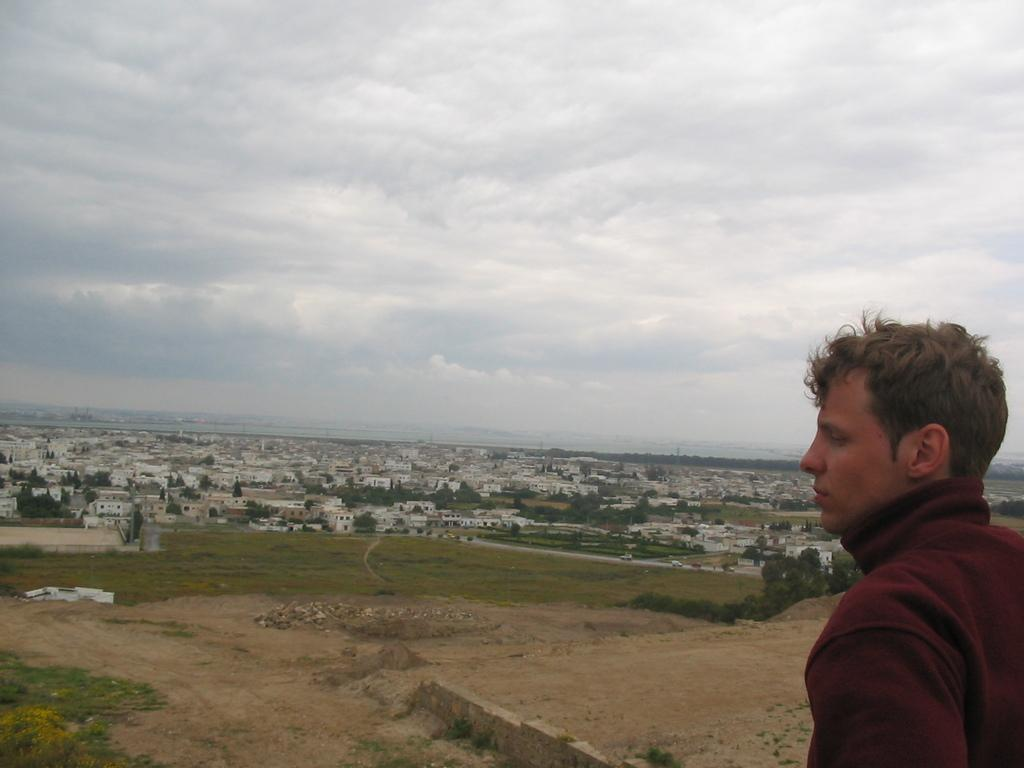Who or what is on the right side of the image? There is a person on the right side of the image. What can be seen in the background of the image? There are houses, buildings, trees, and grass in the background of the image. What is the condition of the sky in the image? The sky is cloudy and visible at the top of the image. What flavor of snails can be seen in the image? There are no snails present in the image, and therefore no flavor can be determined. 